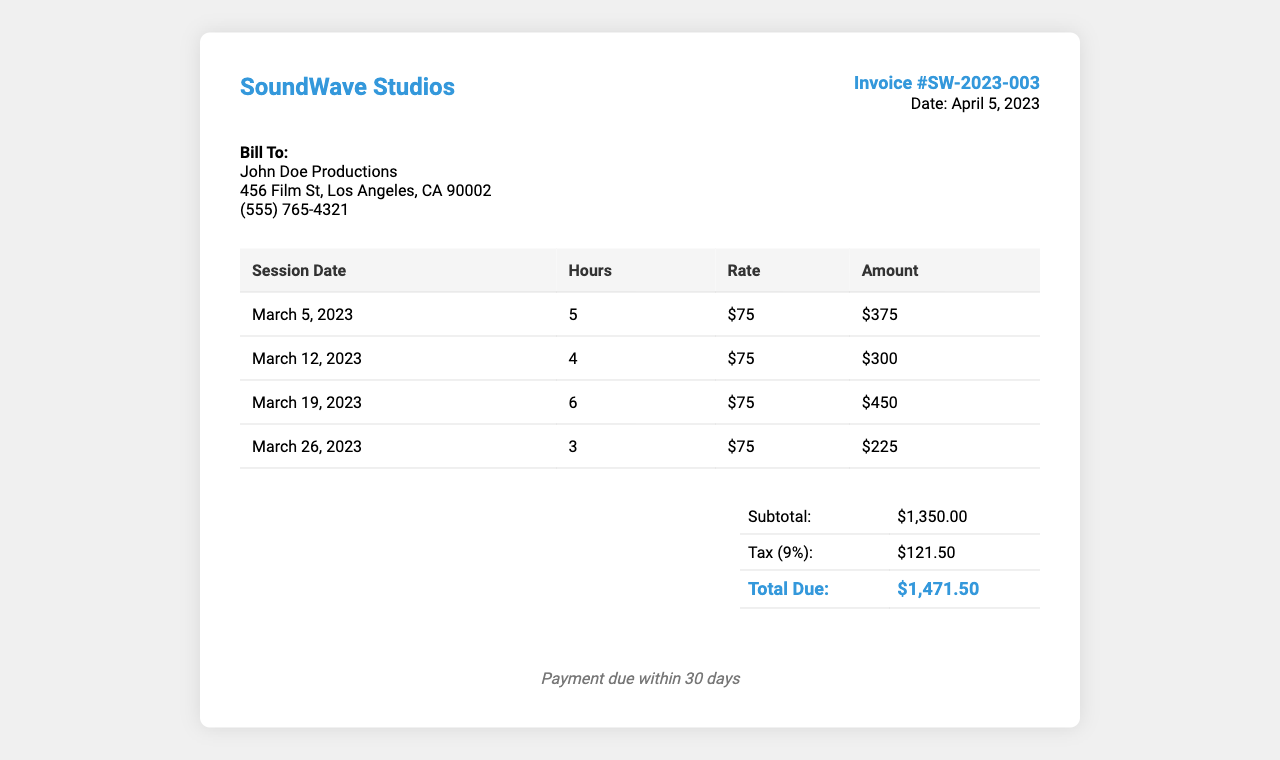What is the invoice number? The invoice number is indicated at the top of the document and is uniquely assigned to this transaction.
Answer: SW-2023-003 What is the total due amount? The total due amount is found in the total section of the invoice, summarizing the subtotal and tax.
Answer: $1,471.50 How many hours were utilized for the session on March 12, 2023? The number of hours for each session is listed in the respective rows of the invoice.
Answer: 4 What was the hourly rate for the recording sessions? The hourly rate is consistently mentioned for all sessions, which contributes to the total amount charged.
Answer: $75 What date was this invoice issued? The date the invoice was generated is prominently displayed in the invoice details.
Answer: April 5, 2023 How many total sessions are recorded in the invoice? The document lists each session on a new line, allowing the total count of individual sessions to be determined easily.
Answer: 4 What is the subtotal before tax? The subtotal is found in the total section and represents the total amount before any tax is applied.
Answer: $1,350.00 What is the tax percentage applied to the subtotal? The tax percentage is indicated in the total section as a calculated amount based on the subtotal.
Answer: 9% What are the payment terms stated in the invoice? The payment terms outline the expectation for payment timing and are typically found near the bottom of the invoice.
Answer: Payment due within 30 days 